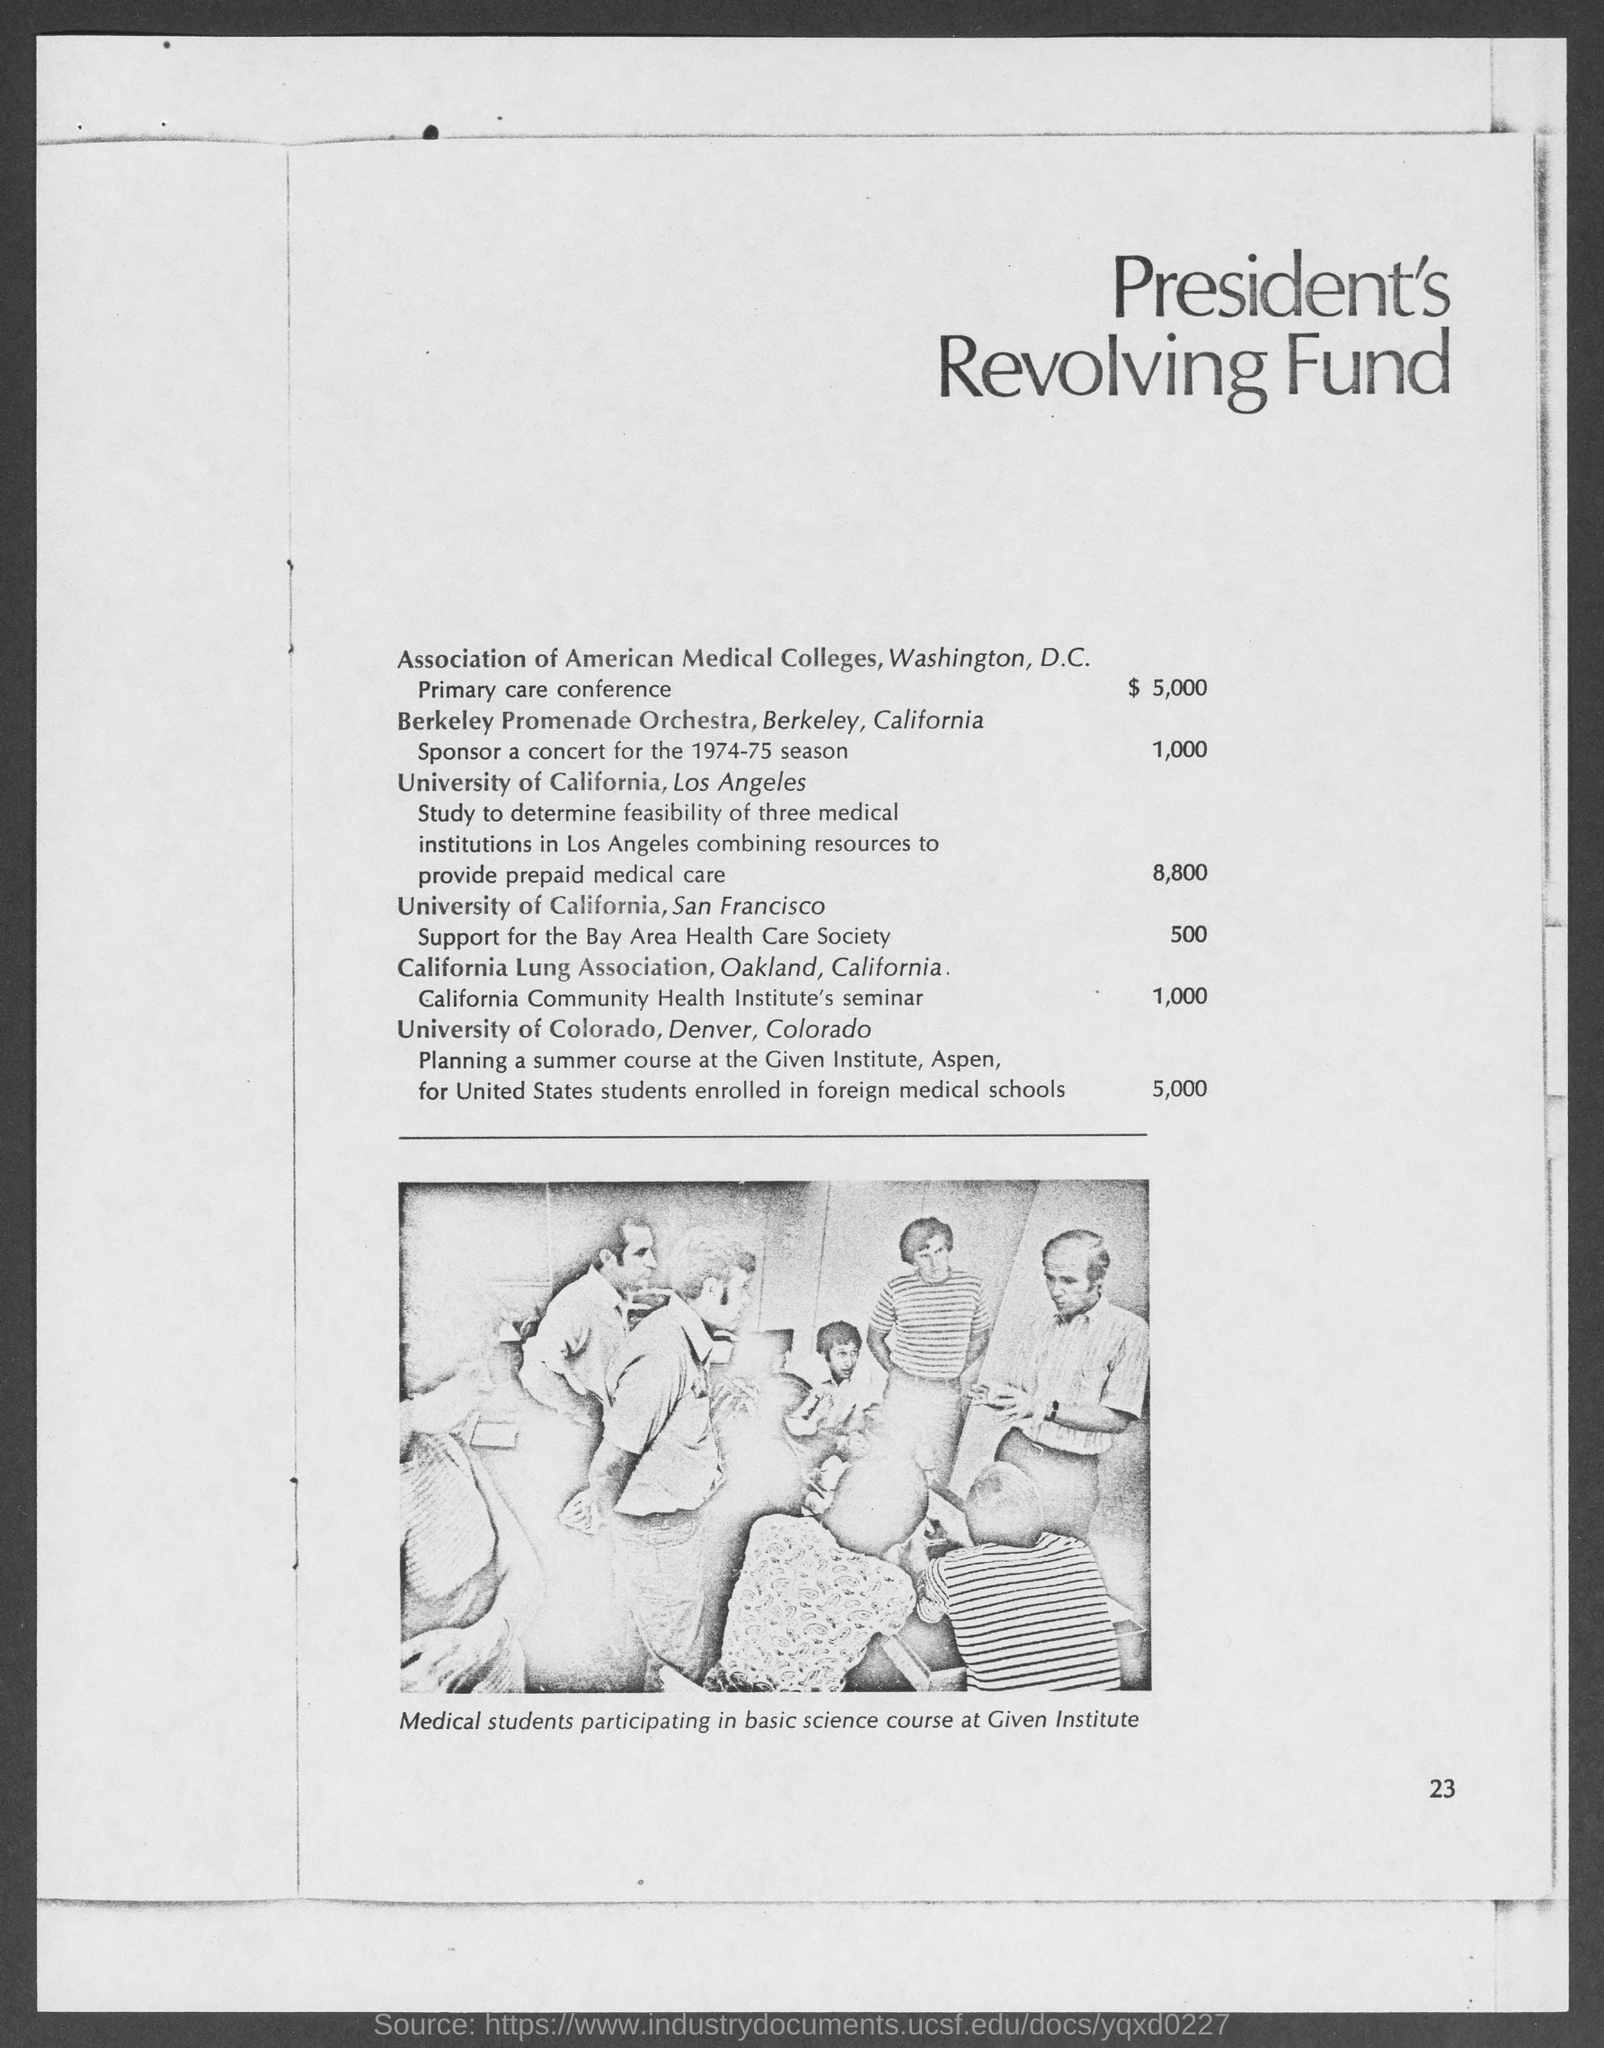What is the page no mentioned in this document?
Give a very brief answer. 23. What is the President's Revolving Fund for Association of American Medical Colleges, Washington, D.C. for Primary care conference?
Provide a succinct answer. $ 5,000. What does the picture in this document demonstrate?
Provide a succinct answer. Medical students participating in basic science course at Given Institute. 